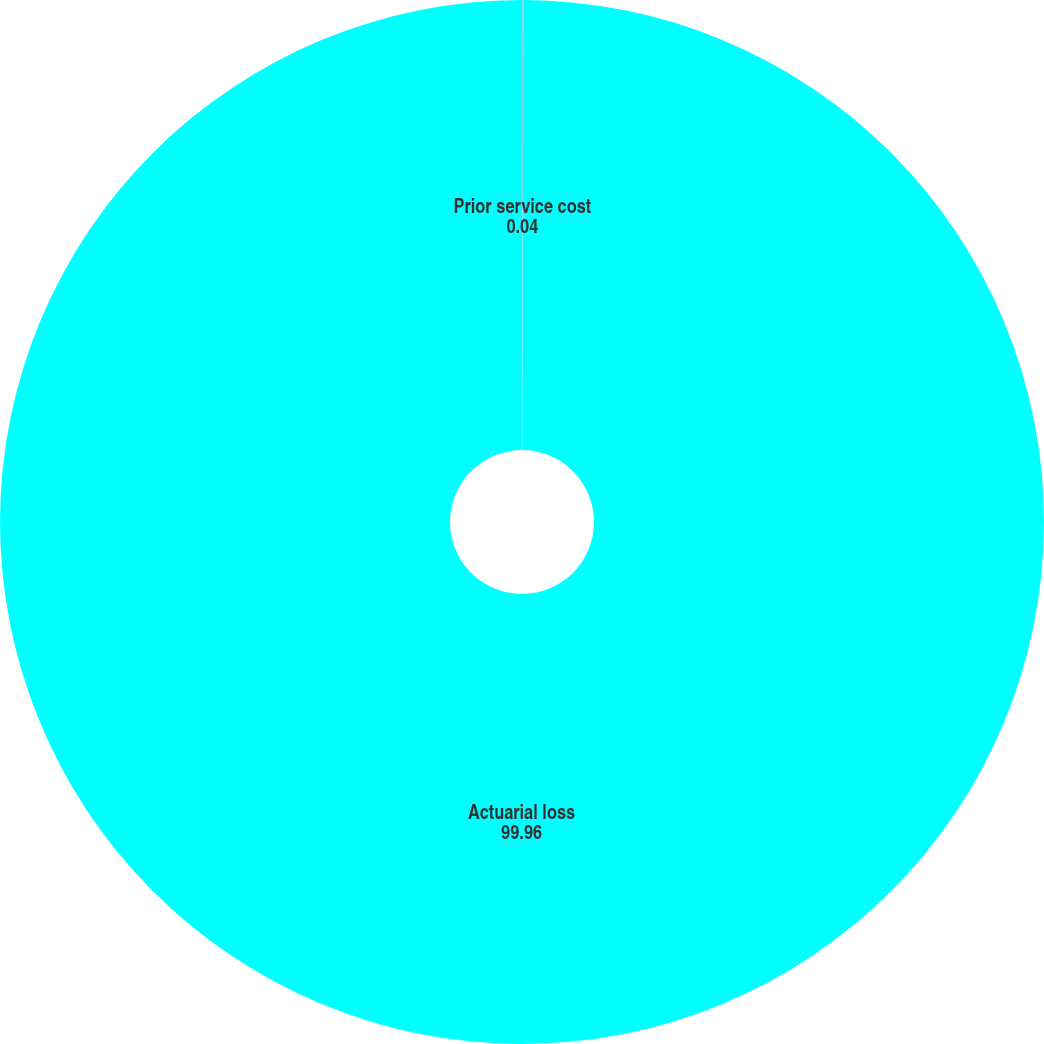Convert chart to OTSL. <chart><loc_0><loc_0><loc_500><loc_500><pie_chart><fcel>Prior service cost<fcel>Actuarial loss<nl><fcel>0.04%<fcel>99.96%<nl></chart> 